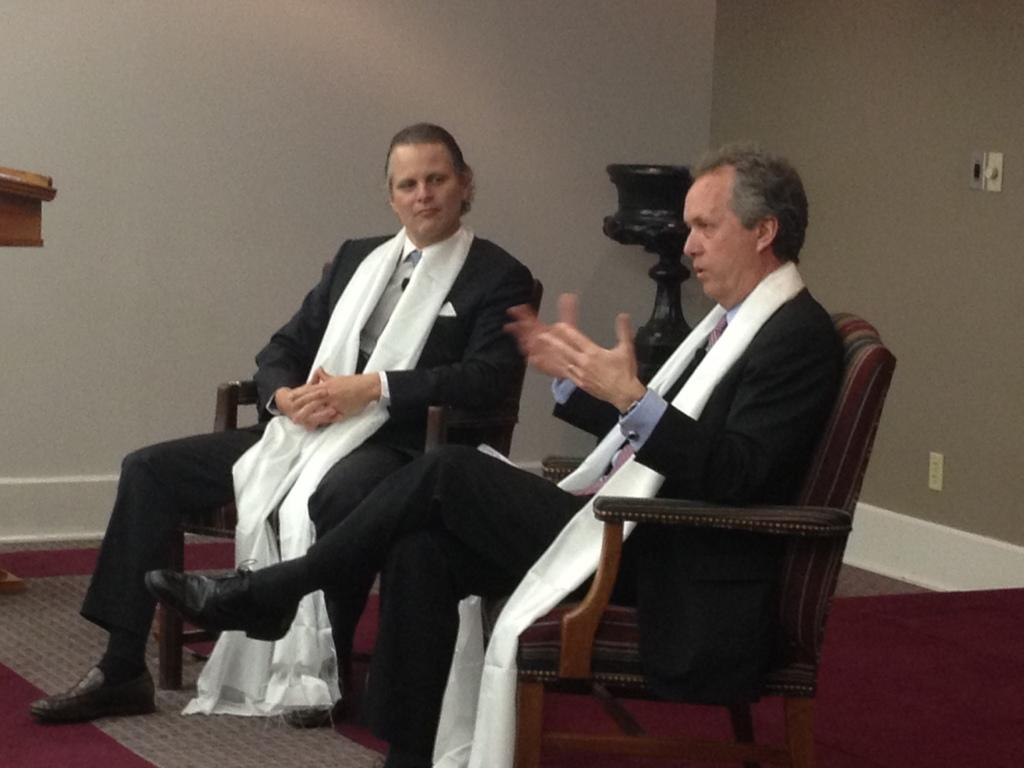How many people are in the image? There are two people in the image. What are the people doing in the image? The people are sitting on chairs. What are the people wearing in the image? The people are wearing black and white dresses. What can be seen in the background of the image? There is a black object and a wall in the background of the image. What type of page is being discussed by the committee in the image? There is no mention of a page or committee in the image; it features two people sitting on chairs wearing black and white dresses. 